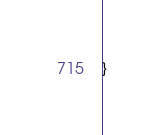<code> <loc_0><loc_0><loc_500><loc_500><_Java_>
}
</code> 